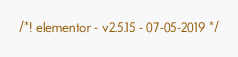Convert code to text. <code><loc_0><loc_0><loc_500><loc_500><_CSS_>/*! elementor - v2.5.15 - 07-05-2019 */</code> 